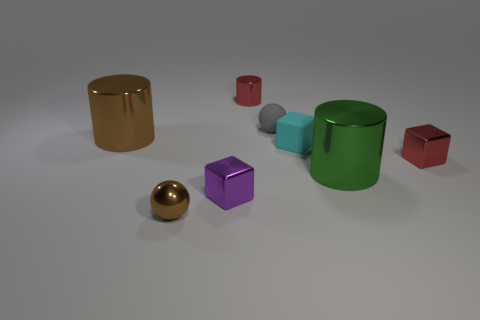How many tiny blocks have the same color as the tiny rubber sphere?
Your answer should be compact. 0. Is the number of blue matte cylinders less than the number of objects?
Ensure brevity in your answer.  Yes. Does the gray thing have the same material as the small brown ball?
Your answer should be very brief. No. What number of other things are there of the same size as the brown shiny cylinder?
Make the answer very short. 1. There is a big thing that is to the right of the big brown object that is to the left of the big green metal cylinder; what color is it?
Give a very brief answer. Green. How many other objects are the same shape as the big green shiny object?
Make the answer very short. 2. Are there any tiny purple spheres that have the same material as the small red cube?
Offer a terse response. No. There is a sphere that is the same size as the gray object; what material is it?
Give a very brief answer. Metal. What color is the tiny thing on the right side of the shiny cylinder that is in front of the brown shiny thing that is behind the small matte block?
Provide a short and direct response. Red. Does the thing that is left of the brown sphere have the same shape as the small metallic thing that is on the right side of the big green metallic thing?
Keep it short and to the point. No. 